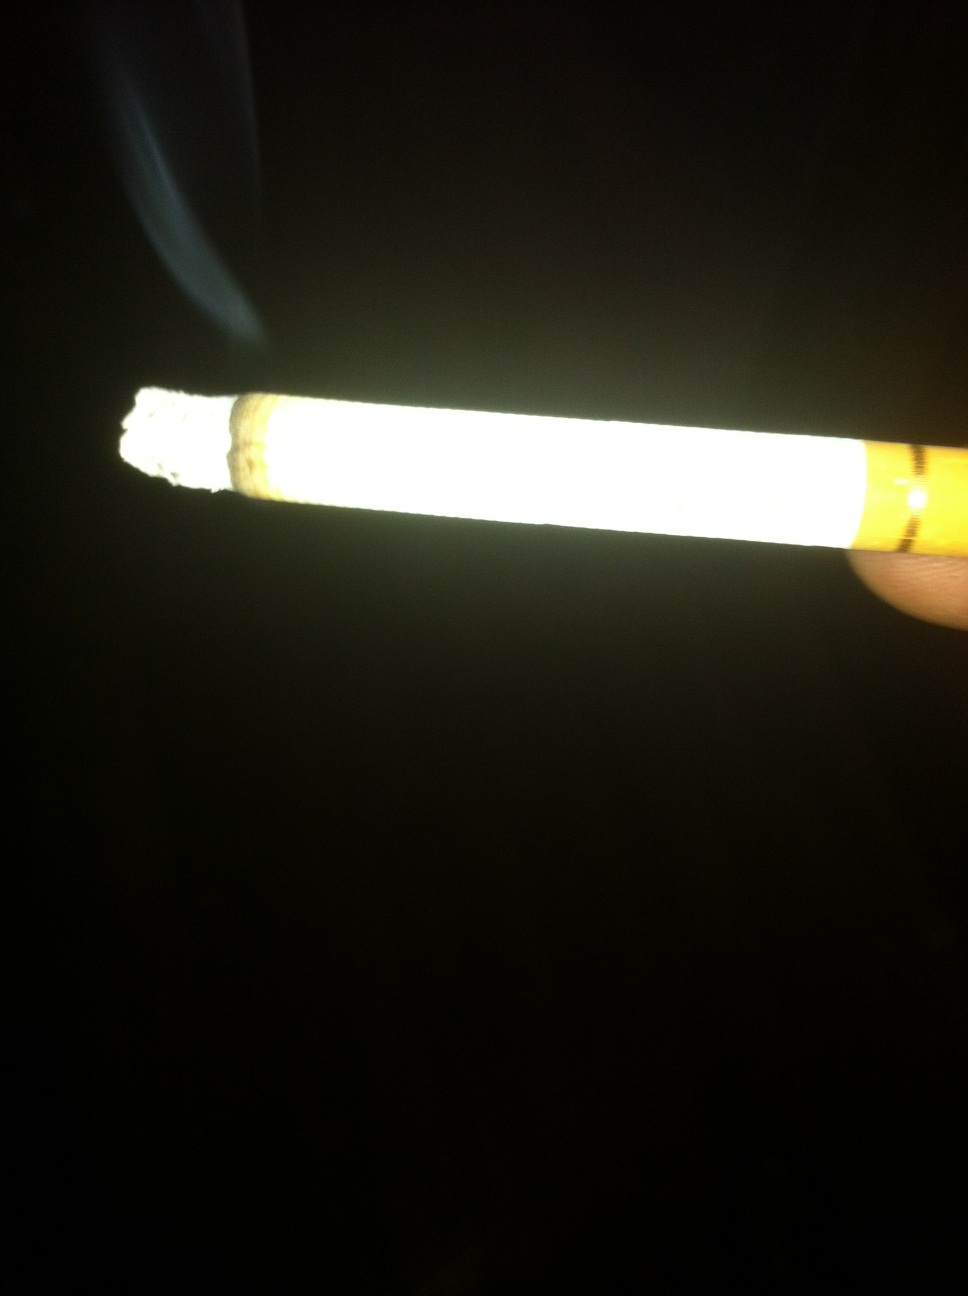what does this look like? from Vizwiz The image depicts a lit cigarette being held against a dark background, with a visible glow at the burning end and a trail of smoke rising upwards. 